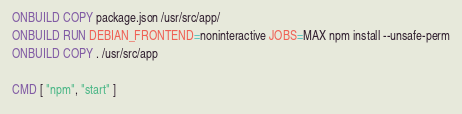<code> <loc_0><loc_0><loc_500><loc_500><_Dockerfile_>ONBUILD COPY package.json /usr/src/app/
ONBUILD RUN DEBIAN_FRONTEND=noninteractive JOBS=MAX npm install --unsafe-perm
ONBUILD COPY . /usr/src/app

CMD [ "npm", "start" ]
</code> 